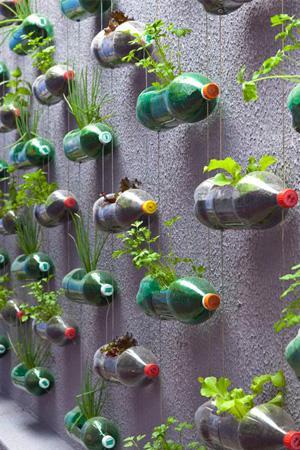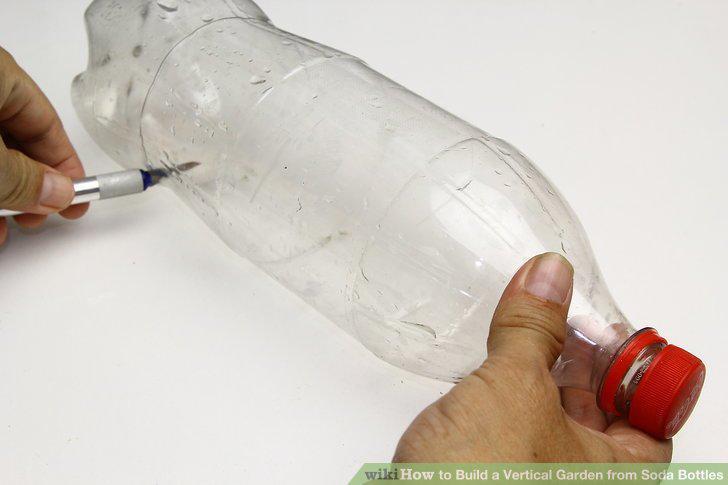The first image is the image on the left, the second image is the image on the right. For the images displayed, is the sentence "The bottles in one of the images are attached to a wall as planters." factually correct? Answer yes or no. Yes. 